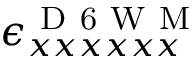Convert formula to latex. <formula><loc_0><loc_0><loc_500><loc_500>\epsilon _ { x x x x x x } ^ { D 6 W M }</formula> 